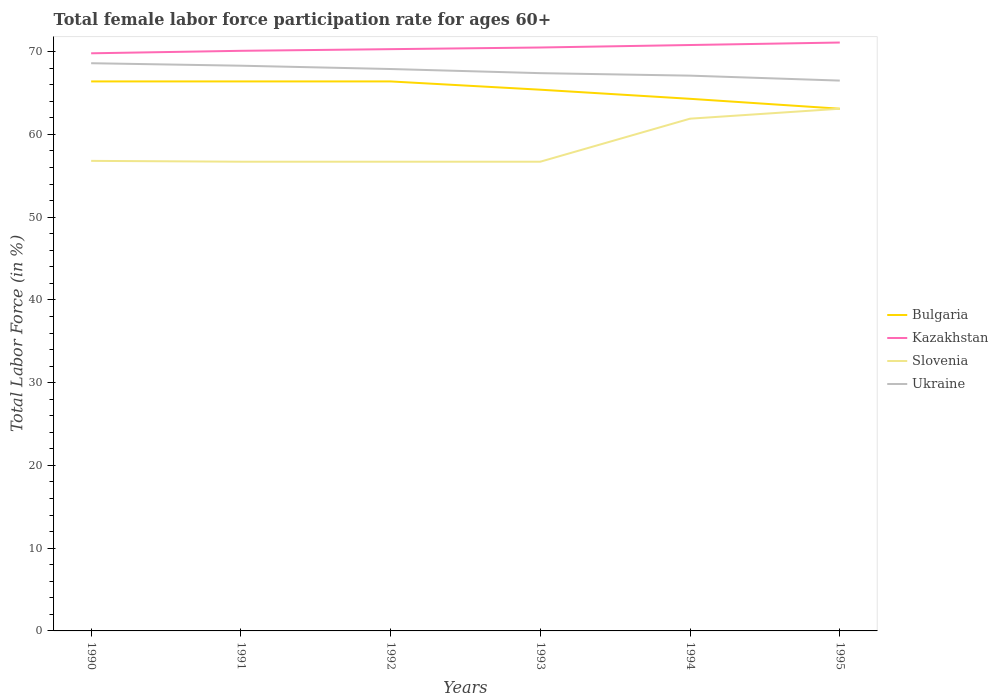How many different coloured lines are there?
Your answer should be compact. 4. Across all years, what is the maximum female labor force participation rate in Kazakhstan?
Your answer should be very brief. 69.8. In which year was the female labor force participation rate in Kazakhstan maximum?
Ensure brevity in your answer.  1990. What is the total female labor force participation rate in Bulgaria in the graph?
Ensure brevity in your answer.  0. What is the difference between the highest and the second highest female labor force participation rate in Ukraine?
Provide a short and direct response. 2.1. Is the female labor force participation rate in Bulgaria strictly greater than the female labor force participation rate in Slovenia over the years?
Ensure brevity in your answer.  No. What is the difference between two consecutive major ticks on the Y-axis?
Provide a short and direct response. 10. Are the values on the major ticks of Y-axis written in scientific E-notation?
Your answer should be compact. No. Where does the legend appear in the graph?
Offer a very short reply. Center right. What is the title of the graph?
Keep it short and to the point. Total female labor force participation rate for ages 60+. Does "Turkmenistan" appear as one of the legend labels in the graph?
Give a very brief answer. No. What is the Total Labor Force (in %) in Bulgaria in 1990?
Offer a terse response. 66.4. What is the Total Labor Force (in %) in Kazakhstan in 1990?
Ensure brevity in your answer.  69.8. What is the Total Labor Force (in %) of Slovenia in 1990?
Your answer should be very brief. 56.8. What is the Total Labor Force (in %) of Ukraine in 1990?
Give a very brief answer. 68.6. What is the Total Labor Force (in %) of Bulgaria in 1991?
Provide a succinct answer. 66.4. What is the Total Labor Force (in %) of Kazakhstan in 1991?
Offer a terse response. 70.1. What is the Total Labor Force (in %) in Slovenia in 1991?
Keep it short and to the point. 56.7. What is the Total Labor Force (in %) in Ukraine in 1991?
Ensure brevity in your answer.  68.3. What is the Total Labor Force (in %) of Bulgaria in 1992?
Your answer should be very brief. 66.4. What is the Total Labor Force (in %) in Kazakhstan in 1992?
Give a very brief answer. 70.3. What is the Total Labor Force (in %) in Slovenia in 1992?
Offer a very short reply. 56.7. What is the Total Labor Force (in %) of Ukraine in 1992?
Offer a very short reply. 67.9. What is the Total Labor Force (in %) of Bulgaria in 1993?
Provide a succinct answer. 65.4. What is the Total Labor Force (in %) in Kazakhstan in 1993?
Offer a very short reply. 70.5. What is the Total Labor Force (in %) in Slovenia in 1993?
Keep it short and to the point. 56.7. What is the Total Labor Force (in %) of Ukraine in 1993?
Keep it short and to the point. 67.4. What is the Total Labor Force (in %) in Bulgaria in 1994?
Ensure brevity in your answer.  64.3. What is the Total Labor Force (in %) of Kazakhstan in 1994?
Provide a succinct answer. 70.8. What is the Total Labor Force (in %) of Slovenia in 1994?
Ensure brevity in your answer.  61.9. What is the Total Labor Force (in %) in Ukraine in 1994?
Make the answer very short. 67.1. What is the Total Labor Force (in %) of Bulgaria in 1995?
Give a very brief answer. 63.1. What is the Total Labor Force (in %) of Kazakhstan in 1995?
Offer a very short reply. 71.1. What is the Total Labor Force (in %) of Slovenia in 1995?
Provide a short and direct response. 63.1. What is the Total Labor Force (in %) of Ukraine in 1995?
Keep it short and to the point. 66.5. Across all years, what is the maximum Total Labor Force (in %) in Bulgaria?
Provide a short and direct response. 66.4. Across all years, what is the maximum Total Labor Force (in %) in Kazakhstan?
Your response must be concise. 71.1. Across all years, what is the maximum Total Labor Force (in %) of Slovenia?
Your answer should be very brief. 63.1. Across all years, what is the maximum Total Labor Force (in %) of Ukraine?
Provide a succinct answer. 68.6. Across all years, what is the minimum Total Labor Force (in %) of Bulgaria?
Your answer should be very brief. 63.1. Across all years, what is the minimum Total Labor Force (in %) of Kazakhstan?
Make the answer very short. 69.8. Across all years, what is the minimum Total Labor Force (in %) in Slovenia?
Give a very brief answer. 56.7. Across all years, what is the minimum Total Labor Force (in %) of Ukraine?
Your answer should be compact. 66.5. What is the total Total Labor Force (in %) in Bulgaria in the graph?
Your response must be concise. 392. What is the total Total Labor Force (in %) in Kazakhstan in the graph?
Offer a very short reply. 422.6. What is the total Total Labor Force (in %) in Slovenia in the graph?
Your answer should be compact. 351.9. What is the total Total Labor Force (in %) in Ukraine in the graph?
Ensure brevity in your answer.  405.8. What is the difference between the Total Labor Force (in %) in Kazakhstan in 1990 and that in 1991?
Keep it short and to the point. -0.3. What is the difference between the Total Labor Force (in %) in Bulgaria in 1990 and that in 1992?
Ensure brevity in your answer.  0. What is the difference between the Total Labor Force (in %) of Slovenia in 1990 and that in 1992?
Your response must be concise. 0.1. What is the difference between the Total Labor Force (in %) in Bulgaria in 1990 and that in 1993?
Your answer should be compact. 1. What is the difference between the Total Labor Force (in %) in Kazakhstan in 1990 and that in 1993?
Ensure brevity in your answer.  -0.7. What is the difference between the Total Labor Force (in %) of Slovenia in 1990 and that in 1993?
Offer a terse response. 0.1. What is the difference between the Total Labor Force (in %) of Slovenia in 1990 and that in 1994?
Provide a short and direct response. -5.1. What is the difference between the Total Labor Force (in %) in Ukraine in 1990 and that in 1994?
Provide a short and direct response. 1.5. What is the difference between the Total Labor Force (in %) in Kazakhstan in 1990 and that in 1995?
Keep it short and to the point. -1.3. What is the difference between the Total Labor Force (in %) in Slovenia in 1990 and that in 1995?
Ensure brevity in your answer.  -6.3. What is the difference between the Total Labor Force (in %) in Bulgaria in 1991 and that in 1992?
Your response must be concise. 0. What is the difference between the Total Labor Force (in %) of Ukraine in 1991 and that in 1992?
Your answer should be very brief. 0.4. What is the difference between the Total Labor Force (in %) of Bulgaria in 1991 and that in 1993?
Offer a very short reply. 1. What is the difference between the Total Labor Force (in %) of Kazakhstan in 1991 and that in 1993?
Offer a terse response. -0.4. What is the difference between the Total Labor Force (in %) in Slovenia in 1991 and that in 1993?
Make the answer very short. 0. What is the difference between the Total Labor Force (in %) of Bulgaria in 1991 and that in 1994?
Your response must be concise. 2.1. What is the difference between the Total Labor Force (in %) in Kazakhstan in 1991 and that in 1994?
Offer a very short reply. -0.7. What is the difference between the Total Labor Force (in %) in Ukraine in 1991 and that in 1994?
Keep it short and to the point. 1.2. What is the difference between the Total Labor Force (in %) of Bulgaria in 1991 and that in 1995?
Your answer should be very brief. 3.3. What is the difference between the Total Labor Force (in %) of Kazakhstan in 1991 and that in 1995?
Your answer should be compact. -1. What is the difference between the Total Labor Force (in %) in Slovenia in 1991 and that in 1995?
Provide a short and direct response. -6.4. What is the difference between the Total Labor Force (in %) in Ukraine in 1991 and that in 1995?
Give a very brief answer. 1.8. What is the difference between the Total Labor Force (in %) in Bulgaria in 1992 and that in 1993?
Make the answer very short. 1. What is the difference between the Total Labor Force (in %) in Kazakhstan in 1992 and that in 1993?
Your response must be concise. -0.2. What is the difference between the Total Labor Force (in %) in Slovenia in 1992 and that in 1993?
Ensure brevity in your answer.  0. What is the difference between the Total Labor Force (in %) of Kazakhstan in 1992 and that in 1994?
Provide a short and direct response. -0.5. What is the difference between the Total Labor Force (in %) of Slovenia in 1992 and that in 1994?
Your answer should be very brief. -5.2. What is the difference between the Total Labor Force (in %) in Ukraine in 1992 and that in 1994?
Provide a short and direct response. 0.8. What is the difference between the Total Labor Force (in %) of Bulgaria in 1992 and that in 1995?
Your answer should be compact. 3.3. What is the difference between the Total Labor Force (in %) in Slovenia in 1992 and that in 1995?
Your answer should be very brief. -6.4. What is the difference between the Total Labor Force (in %) in Kazakhstan in 1993 and that in 1994?
Your answer should be very brief. -0.3. What is the difference between the Total Labor Force (in %) of Slovenia in 1993 and that in 1994?
Keep it short and to the point. -5.2. What is the difference between the Total Labor Force (in %) in Kazakhstan in 1993 and that in 1995?
Give a very brief answer. -0.6. What is the difference between the Total Labor Force (in %) in Slovenia in 1993 and that in 1995?
Your answer should be compact. -6.4. What is the difference between the Total Labor Force (in %) of Slovenia in 1994 and that in 1995?
Your response must be concise. -1.2. What is the difference between the Total Labor Force (in %) of Ukraine in 1994 and that in 1995?
Ensure brevity in your answer.  0.6. What is the difference between the Total Labor Force (in %) in Bulgaria in 1990 and the Total Labor Force (in %) in Kazakhstan in 1991?
Make the answer very short. -3.7. What is the difference between the Total Labor Force (in %) in Bulgaria in 1990 and the Total Labor Force (in %) in Ukraine in 1991?
Provide a succinct answer. -1.9. What is the difference between the Total Labor Force (in %) in Kazakhstan in 1990 and the Total Labor Force (in %) in Slovenia in 1991?
Your answer should be very brief. 13.1. What is the difference between the Total Labor Force (in %) in Kazakhstan in 1990 and the Total Labor Force (in %) in Ukraine in 1991?
Your answer should be very brief. 1.5. What is the difference between the Total Labor Force (in %) of Slovenia in 1990 and the Total Labor Force (in %) of Ukraine in 1991?
Your answer should be very brief. -11.5. What is the difference between the Total Labor Force (in %) in Bulgaria in 1990 and the Total Labor Force (in %) in Kazakhstan in 1992?
Provide a short and direct response. -3.9. What is the difference between the Total Labor Force (in %) in Bulgaria in 1990 and the Total Labor Force (in %) in Ukraine in 1992?
Ensure brevity in your answer.  -1.5. What is the difference between the Total Labor Force (in %) of Slovenia in 1990 and the Total Labor Force (in %) of Ukraine in 1992?
Provide a succinct answer. -11.1. What is the difference between the Total Labor Force (in %) in Bulgaria in 1990 and the Total Labor Force (in %) in Slovenia in 1993?
Your answer should be very brief. 9.7. What is the difference between the Total Labor Force (in %) in Kazakhstan in 1990 and the Total Labor Force (in %) in Slovenia in 1993?
Provide a succinct answer. 13.1. What is the difference between the Total Labor Force (in %) of Kazakhstan in 1990 and the Total Labor Force (in %) of Ukraine in 1993?
Keep it short and to the point. 2.4. What is the difference between the Total Labor Force (in %) of Bulgaria in 1990 and the Total Labor Force (in %) of Kazakhstan in 1994?
Your answer should be very brief. -4.4. What is the difference between the Total Labor Force (in %) of Bulgaria in 1990 and the Total Labor Force (in %) of Ukraine in 1994?
Ensure brevity in your answer.  -0.7. What is the difference between the Total Labor Force (in %) in Kazakhstan in 1990 and the Total Labor Force (in %) in Slovenia in 1994?
Your response must be concise. 7.9. What is the difference between the Total Labor Force (in %) of Kazakhstan in 1990 and the Total Labor Force (in %) of Ukraine in 1994?
Offer a very short reply. 2.7. What is the difference between the Total Labor Force (in %) of Slovenia in 1990 and the Total Labor Force (in %) of Ukraine in 1994?
Your answer should be very brief. -10.3. What is the difference between the Total Labor Force (in %) in Bulgaria in 1990 and the Total Labor Force (in %) in Kazakhstan in 1995?
Offer a very short reply. -4.7. What is the difference between the Total Labor Force (in %) in Bulgaria in 1990 and the Total Labor Force (in %) in Ukraine in 1995?
Make the answer very short. -0.1. What is the difference between the Total Labor Force (in %) of Kazakhstan in 1990 and the Total Labor Force (in %) of Ukraine in 1995?
Ensure brevity in your answer.  3.3. What is the difference between the Total Labor Force (in %) of Bulgaria in 1991 and the Total Labor Force (in %) of Ukraine in 1992?
Offer a terse response. -1.5. What is the difference between the Total Labor Force (in %) in Slovenia in 1991 and the Total Labor Force (in %) in Ukraine in 1992?
Keep it short and to the point. -11.2. What is the difference between the Total Labor Force (in %) of Bulgaria in 1991 and the Total Labor Force (in %) of Kazakhstan in 1993?
Provide a short and direct response. -4.1. What is the difference between the Total Labor Force (in %) in Kazakhstan in 1991 and the Total Labor Force (in %) in Slovenia in 1993?
Give a very brief answer. 13.4. What is the difference between the Total Labor Force (in %) of Kazakhstan in 1991 and the Total Labor Force (in %) of Ukraine in 1993?
Your answer should be very brief. 2.7. What is the difference between the Total Labor Force (in %) in Slovenia in 1991 and the Total Labor Force (in %) in Ukraine in 1993?
Ensure brevity in your answer.  -10.7. What is the difference between the Total Labor Force (in %) of Bulgaria in 1991 and the Total Labor Force (in %) of Kazakhstan in 1994?
Provide a short and direct response. -4.4. What is the difference between the Total Labor Force (in %) of Bulgaria in 1991 and the Total Labor Force (in %) of Slovenia in 1994?
Offer a very short reply. 4.5. What is the difference between the Total Labor Force (in %) of Kazakhstan in 1991 and the Total Labor Force (in %) of Ukraine in 1994?
Provide a short and direct response. 3. What is the difference between the Total Labor Force (in %) of Slovenia in 1991 and the Total Labor Force (in %) of Ukraine in 1994?
Keep it short and to the point. -10.4. What is the difference between the Total Labor Force (in %) of Bulgaria in 1991 and the Total Labor Force (in %) of Kazakhstan in 1995?
Make the answer very short. -4.7. What is the difference between the Total Labor Force (in %) of Kazakhstan in 1991 and the Total Labor Force (in %) of Slovenia in 1995?
Offer a terse response. 7. What is the difference between the Total Labor Force (in %) of Kazakhstan in 1991 and the Total Labor Force (in %) of Ukraine in 1995?
Your response must be concise. 3.6. What is the difference between the Total Labor Force (in %) in Bulgaria in 1992 and the Total Labor Force (in %) in Kazakhstan in 1993?
Your response must be concise. -4.1. What is the difference between the Total Labor Force (in %) in Bulgaria in 1992 and the Total Labor Force (in %) in Ukraine in 1993?
Provide a succinct answer. -1. What is the difference between the Total Labor Force (in %) in Kazakhstan in 1992 and the Total Labor Force (in %) in Slovenia in 1993?
Give a very brief answer. 13.6. What is the difference between the Total Labor Force (in %) in Kazakhstan in 1992 and the Total Labor Force (in %) in Ukraine in 1993?
Make the answer very short. 2.9. What is the difference between the Total Labor Force (in %) in Slovenia in 1992 and the Total Labor Force (in %) in Ukraine in 1993?
Provide a short and direct response. -10.7. What is the difference between the Total Labor Force (in %) in Bulgaria in 1992 and the Total Labor Force (in %) in Kazakhstan in 1994?
Offer a terse response. -4.4. What is the difference between the Total Labor Force (in %) of Bulgaria in 1992 and the Total Labor Force (in %) of Slovenia in 1994?
Provide a short and direct response. 4.5. What is the difference between the Total Labor Force (in %) of Bulgaria in 1992 and the Total Labor Force (in %) of Ukraine in 1994?
Your answer should be very brief. -0.7. What is the difference between the Total Labor Force (in %) in Kazakhstan in 1992 and the Total Labor Force (in %) in Ukraine in 1994?
Your answer should be very brief. 3.2. What is the difference between the Total Labor Force (in %) in Slovenia in 1992 and the Total Labor Force (in %) in Ukraine in 1994?
Offer a terse response. -10.4. What is the difference between the Total Labor Force (in %) in Bulgaria in 1992 and the Total Labor Force (in %) in Slovenia in 1995?
Your answer should be compact. 3.3. What is the difference between the Total Labor Force (in %) of Bulgaria in 1992 and the Total Labor Force (in %) of Ukraine in 1995?
Offer a very short reply. -0.1. What is the difference between the Total Labor Force (in %) of Kazakhstan in 1992 and the Total Labor Force (in %) of Ukraine in 1995?
Your response must be concise. 3.8. What is the difference between the Total Labor Force (in %) of Slovenia in 1992 and the Total Labor Force (in %) of Ukraine in 1995?
Your answer should be compact. -9.8. What is the difference between the Total Labor Force (in %) of Bulgaria in 1993 and the Total Labor Force (in %) of Slovenia in 1994?
Offer a terse response. 3.5. What is the difference between the Total Labor Force (in %) of Kazakhstan in 1993 and the Total Labor Force (in %) of Slovenia in 1994?
Your answer should be very brief. 8.6. What is the difference between the Total Labor Force (in %) in Kazakhstan in 1993 and the Total Labor Force (in %) in Ukraine in 1994?
Offer a very short reply. 3.4. What is the difference between the Total Labor Force (in %) in Bulgaria in 1993 and the Total Labor Force (in %) in Kazakhstan in 1995?
Make the answer very short. -5.7. What is the difference between the Total Labor Force (in %) of Bulgaria in 1993 and the Total Labor Force (in %) of Slovenia in 1995?
Keep it short and to the point. 2.3. What is the difference between the Total Labor Force (in %) of Kazakhstan in 1993 and the Total Labor Force (in %) of Slovenia in 1995?
Your response must be concise. 7.4. What is the difference between the Total Labor Force (in %) of Slovenia in 1994 and the Total Labor Force (in %) of Ukraine in 1995?
Your answer should be compact. -4.6. What is the average Total Labor Force (in %) of Bulgaria per year?
Your answer should be very brief. 65.33. What is the average Total Labor Force (in %) of Kazakhstan per year?
Offer a very short reply. 70.43. What is the average Total Labor Force (in %) in Slovenia per year?
Offer a very short reply. 58.65. What is the average Total Labor Force (in %) of Ukraine per year?
Ensure brevity in your answer.  67.63. In the year 1990, what is the difference between the Total Labor Force (in %) of Bulgaria and Total Labor Force (in %) of Kazakhstan?
Give a very brief answer. -3.4. In the year 1990, what is the difference between the Total Labor Force (in %) in Bulgaria and Total Labor Force (in %) in Ukraine?
Give a very brief answer. -2.2. In the year 1990, what is the difference between the Total Labor Force (in %) in Kazakhstan and Total Labor Force (in %) in Slovenia?
Give a very brief answer. 13. In the year 1990, what is the difference between the Total Labor Force (in %) in Kazakhstan and Total Labor Force (in %) in Ukraine?
Make the answer very short. 1.2. In the year 1990, what is the difference between the Total Labor Force (in %) of Slovenia and Total Labor Force (in %) of Ukraine?
Make the answer very short. -11.8. In the year 1991, what is the difference between the Total Labor Force (in %) of Bulgaria and Total Labor Force (in %) of Slovenia?
Your answer should be compact. 9.7. In the year 1991, what is the difference between the Total Labor Force (in %) in Kazakhstan and Total Labor Force (in %) in Slovenia?
Make the answer very short. 13.4. In the year 1992, what is the difference between the Total Labor Force (in %) in Bulgaria and Total Labor Force (in %) in Ukraine?
Your answer should be compact. -1.5. In the year 1992, what is the difference between the Total Labor Force (in %) of Slovenia and Total Labor Force (in %) of Ukraine?
Offer a terse response. -11.2. In the year 1993, what is the difference between the Total Labor Force (in %) of Bulgaria and Total Labor Force (in %) of Slovenia?
Your answer should be very brief. 8.7. In the year 1993, what is the difference between the Total Labor Force (in %) in Kazakhstan and Total Labor Force (in %) in Ukraine?
Provide a short and direct response. 3.1. In the year 1994, what is the difference between the Total Labor Force (in %) in Bulgaria and Total Labor Force (in %) in Kazakhstan?
Your answer should be very brief. -6.5. In the year 1994, what is the difference between the Total Labor Force (in %) of Bulgaria and Total Labor Force (in %) of Ukraine?
Your response must be concise. -2.8. In the year 1995, what is the difference between the Total Labor Force (in %) in Bulgaria and Total Labor Force (in %) in Kazakhstan?
Give a very brief answer. -8. In the year 1995, what is the difference between the Total Labor Force (in %) in Bulgaria and Total Labor Force (in %) in Slovenia?
Your answer should be compact. 0. What is the ratio of the Total Labor Force (in %) in Bulgaria in 1990 to that in 1991?
Offer a terse response. 1. What is the ratio of the Total Labor Force (in %) of Slovenia in 1990 to that in 1991?
Ensure brevity in your answer.  1. What is the ratio of the Total Labor Force (in %) of Ukraine in 1990 to that in 1992?
Make the answer very short. 1.01. What is the ratio of the Total Labor Force (in %) in Bulgaria in 1990 to that in 1993?
Offer a very short reply. 1.02. What is the ratio of the Total Labor Force (in %) in Kazakhstan in 1990 to that in 1993?
Provide a succinct answer. 0.99. What is the ratio of the Total Labor Force (in %) in Ukraine in 1990 to that in 1993?
Provide a short and direct response. 1.02. What is the ratio of the Total Labor Force (in %) of Bulgaria in 1990 to that in 1994?
Give a very brief answer. 1.03. What is the ratio of the Total Labor Force (in %) of Kazakhstan in 1990 to that in 1994?
Keep it short and to the point. 0.99. What is the ratio of the Total Labor Force (in %) of Slovenia in 1990 to that in 1994?
Your answer should be very brief. 0.92. What is the ratio of the Total Labor Force (in %) in Ukraine in 1990 to that in 1994?
Your answer should be compact. 1.02. What is the ratio of the Total Labor Force (in %) of Bulgaria in 1990 to that in 1995?
Your answer should be compact. 1.05. What is the ratio of the Total Labor Force (in %) in Kazakhstan in 1990 to that in 1995?
Provide a short and direct response. 0.98. What is the ratio of the Total Labor Force (in %) of Slovenia in 1990 to that in 1995?
Make the answer very short. 0.9. What is the ratio of the Total Labor Force (in %) of Ukraine in 1990 to that in 1995?
Keep it short and to the point. 1.03. What is the ratio of the Total Labor Force (in %) of Bulgaria in 1991 to that in 1992?
Make the answer very short. 1. What is the ratio of the Total Labor Force (in %) in Kazakhstan in 1991 to that in 1992?
Keep it short and to the point. 1. What is the ratio of the Total Labor Force (in %) in Slovenia in 1991 to that in 1992?
Your answer should be compact. 1. What is the ratio of the Total Labor Force (in %) of Ukraine in 1991 to that in 1992?
Make the answer very short. 1.01. What is the ratio of the Total Labor Force (in %) of Bulgaria in 1991 to that in 1993?
Offer a very short reply. 1.02. What is the ratio of the Total Labor Force (in %) of Slovenia in 1991 to that in 1993?
Your response must be concise. 1. What is the ratio of the Total Labor Force (in %) of Ukraine in 1991 to that in 1993?
Provide a succinct answer. 1.01. What is the ratio of the Total Labor Force (in %) in Bulgaria in 1991 to that in 1994?
Keep it short and to the point. 1.03. What is the ratio of the Total Labor Force (in %) of Kazakhstan in 1991 to that in 1994?
Make the answer very short. 0.99. What is the ratio of the Total Labor Force (in %) of Slovenia in 1991 to that in 1994?
Provide a short and direct response. 0.92. What is the ratio of the Total Labor Force (in %) in Ukraine in 1991 to that in 1994?
Provide a short and direct response. 1.02. What is the ratio of the Total Labor Force (in %) of Bulgaria in 1991 to that in 1995?
Your answer should be very brief. 1.05. What is the ratio of the Total Labor Force (in %) of Kazakhstan in 1991 to that in 1995?
Provide a succinct answer. 0.99. What is the ratio of the Total Labor Force (in %) in Slovenia in 1991 to that in 1995?
Provide a short and direct response. 0.9. What is the ratio of the Total Labor Force (in %) in Ukraine in 1991 to that in 1995?
Ensure brevity in your answer.  1.03. What is the ratio of the Total Labor Force (in %) in Bulgaria in 1992 to that in 1993?
Provide a succinct answer. 1.02. What is the ratio of the Total Labor Force (in %) in Kazakhstan in 1992 to that in 1993?
Make the answer very short. 1. What is the ratio of the Total Labor Force (in %) in Slovenia in 1992 to that in 1993?
Ensure brevity in your answer.  1. What is the ratio of the Total Labor Force (in %) in Ukraine in 1992 to that in 1993?
Your answer should be very brief. 1.01. What is the ratio of the Total Labor Force (in %) of Bulgaria in 1992 to that in 1994?
Keep it short and to the point. 1.03. What is the ratio of the Total Labor Force (in %) in Slovenia in 1992 to that in 1994?
Your response must be concise. 0.92. What is the ratio of the Total Labor Force (in %) of Ukraine in 1992 to that in 1994?
Provide a succinct answer. 1.01. What is the ratio of the Total Labor Force (in %) in Bulgaria in 1992 to that in 1995?
Give a very brief answer. 1.05. What is the ratio of the Total Labor Force (in %) in Kazakhstan in 1992 to that in 1995?
Keep it short and to the point. 0.99. What is the ratio of the Total Labor Force (in %) in Slovenia in 1992 to that in 1995?
Your answer should be very brief. 0.9. What is the ratio of the Total Labor Force (in %) of Ukraine in 1992 to that in 1995?
Offer a very short reply. 1.02. What is the ratio of the Total Labor Force (in %) of Bulgaria in 1993 to that in 1994?
Ensure brevity in your answer.  1.02. What is the ratio of the Total Labor Force (in %) in Kazakhstan in 1993 to that in 1994?
Your answer should be very brief. 1. What is the ratio of the Total Labor Force (in %) in Slovenia in 1993 to that in 1994?
Offer a terse response. 0.92. What is the ratio of the Total Labor Force (in %) in Ukraine in 1993 to that in 1994?
Provide a short and direct response. 1. What is the ratio of the Total Labor Force (in %) in Bulgaria in 1993 to that in 1995?
Your response must be concise. 1.04. What is the ratio of the Total Labor Force (in %) of Kazakhstan in 1993 to that in 1995?
Offer a very short reply. 0.99. What is the ratio of the Total Labor Force (in %) in Slovenia in 1993 to that in 1995?
Give a very brief answer. 0.9. What is the ratio of the Total Labor Force (in %) of Ukraine in 1993 to that in 1995?
Ensure brevity in your answer.  1.01. What is the ratio of the Total Labor Force (in %) of Bulgaria in 1994 to that in 1995?
Offer a terse response. 1.02. What is the ratio of the Total Labor Force (in %) in Slovenia in 1994 to that in 1995?
Provide a succinct answer. 0.98. What is the difference between the highest and the second highest Total Labor Force (in %) of Bulgaria?
Your answer should be compact. 0. What is the difference between the highest and the second highest Total Labor Force (in %) of Slovenia?
Offer a terse response. 1.2. What is the difference between the highest and the lowest Total Labor Force (in %) in Bulgaria?
Offer a terse response. 3.3. What is the difference between the highest and the lowest Total Labor Force (in %) of Kazakhstan?
Keep it short and to the point. 1.3. 